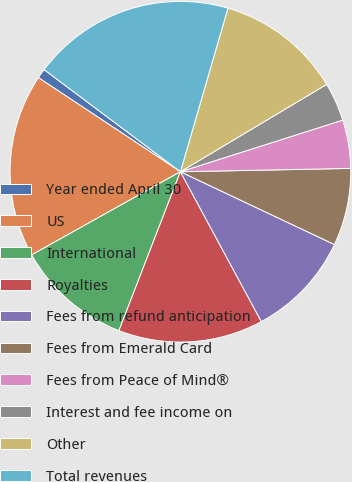Convert chart. <chart><loc_0><loc_0><loc_500><loc_500><pie_chart><fcel>Year ended April 30<fcel>US<fcel>International<fcel>Royalties<fcel>Fees from refund anticipation<fcel>Fees from Emerald Card<fcel>Fees from Peace of Mind®<fcel>Interest and fee income on<fcel>Other<fcel>Total revenues<nl><fcel>0.92%<fcel>17.43%<fcel>11.01%<fcel>13.76%<fcel>10.09%<fcel>7.34%<fcel>4.59%<fcel>3.67%<fcel>11.93%<fcel>19.27%<nl></chart> 